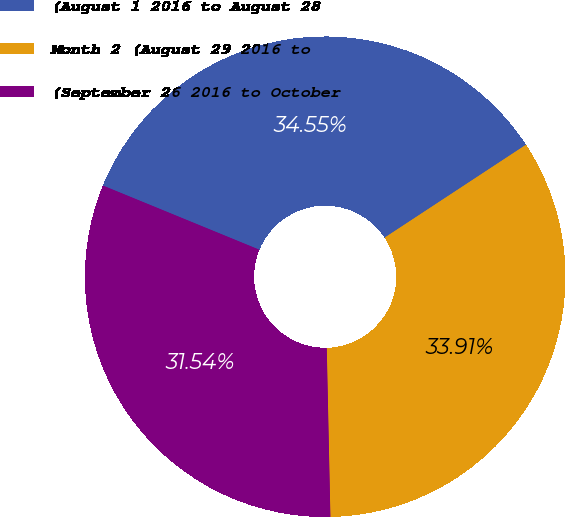Convert chart. <chart><loc_0><loc_0><loc_500><loc_500><pie_chart><fcel>(August 1 2016 to August 28<fcel>Month 2 (August 29 2016 to<fcel>(September 26 2016 to October<nl><fcel>34.55%<fcel>33.91%<fcel>31.54%<nl></chart> 